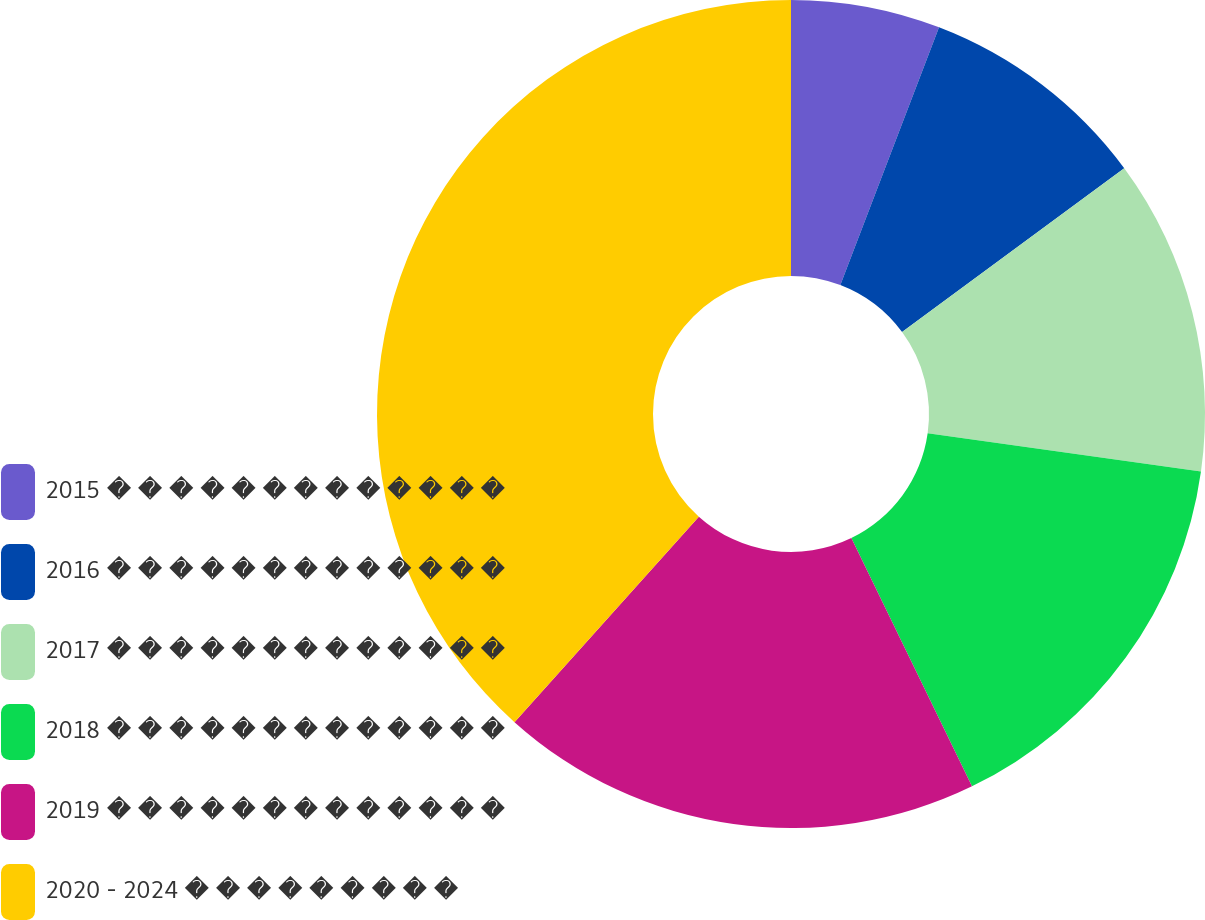<chart> <loc_0><loc_0><loc_500><loc_500><pie_chart><fcel>2015 � � � � � � � � � � � � �<fcel>2016 � � � � � � � � � � � � �<fcel>2017 � � � � � � � � � � � � �<fcel>2018 � � � � � � � � � � � � �<fcel>2019 � � � � � � � � � � � � �<fcel>2020 - 2024 � � � � � � � � �<nl><fcel>5.82%<fcel>9.07%<fcel>12.33%<fcel>15.58%<fcel>18.84%<fcel>38.36%<nl></chart> 